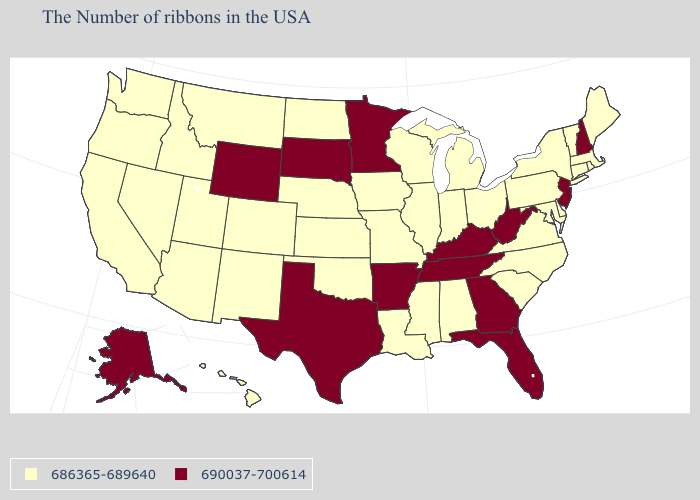Which states have the lowest value in the USA?
Short answer required. Maine, Massachusetts, Rhode Island, Vermont, Connecticut, New York, Delaware, Maryland, Pennsylvania, Virginia, North Carolina, South Carolina, Ohio, Michigan, Indiana, Alabama, Wisconsin, Illinois, Mississippi, Louisiana, Missouri, Iowa, Kansas, Nebraska, Oklahoma, North Dakota, Colorado, New Mexico, Utah, Montana, Arizona, Idaho, Nevada, California, Washington, Oregon, Hawaii. Name the states that have a value in the range 690037-700614?
Write a very short answer. New Hampshire, New Jersey, West Virginia, Florida, Georgia, Kentucky, Tennessee, Arkansas, Minnesota, Texas, South Dakota, Wyoming, Alaska. Does Colorado have the lowest value in the West?
Concise answer only. Yes. Name the states that have a value in the range 690037-700614?
Give a very brief answer. New Hampshire, New Jersey, West Virginia, Florida, Georgia, Kentucky, Tennessee, Arkansas, Minnesota, Texas, South Dakota, Wyoming, Alaska. Is the legend a continuous bar?
Write a very short answer. No. Name the states that have a value in the range 690037-700614?
Give a very brief answer. New Hampshire, New Jersey, West Virginia, Florida, Georgia, Kentucky, Tennessee, Arkansas, Minnesota, Texas, South Dakota, Wyoming, Alaska. What is the highest value in states that border Nevada?
Quick response, please. 686365-689640. What is the highest value in states that border Illinois?
Be succinct. 690037-700614. Among the states that border Maine , which have the lowest value?
Give a very brief answer. New Hampshire. How many symbols are there in the legend?
Concise answer only. 2. Name the states that have a value in the range 690037-700614?
Concise answer only. New Hampshire, New Jersey, West Virginia, Florida, Georgia, Kentucky, Tennessee, Arkansas, Minnesota, Texas, South Dakota, Wyoming, Alaska. Name the states that have a value in the range 686365-689640?
Answer briefly. Maine, Massachusetts, Rhode Island, Vermont, Connecticut, New York, Delaware, Maryland, Pennsylvania, Virginia, North Carolina, South Carolina, Ohio, Michigan, Indiana, Alabama, Wisconsin, Illinois, Mississippi, Louisiana, Missouri, Iowa, Kansas, Nebraska, Oklahoma, North Dakota, Colorado, New Mexico, Utah, Montana, Arizona, Idaho, Nevada, California, Washington, Oregon, Hawaii. Name the states that have a value in the range 686365-689640?
Write a very short answer. Maine, Massachusetts, Rhode Island, Vermont, Connecticut, New York, Delaware, Maryland, Pennsylvania, Virginia, North Carolina, South Carolina, Ohio, Michigan, Indiana, Alabama, Wisconsin, Illinois, Mississippi, Louisiana, Missouri, Iowa, Kansas, Nebraska, Oklahoma, North Dakota, Colorado, New Mexico, Utah, Montana, Arizona, Idaho, Nevada, California, Washington, Oregon, Hawaii. Name the states that have a value in the range 690037-700614?
Quick response, please. New Hampshire, New Jersey, West Virginia, Florida, Georgia, Kentucky, Tennessee, Arkansas, Minnesota, Texas, South Dakota, Wyoming, Alaska. Name the states that have a value in the range 686365-689640?
Concise answer only. Maine, Massachusetts, Rhode Island, Vermont, Connecticut, New York, Delaware, Maryland, Pennsylvania, Virginia, North Carolina, South Carolina, Ohio, Michigan, Indiana, Alabama, Wisconsin, Illinois, Mississippi, Louisiana, Missouri, Iowa, Kansas, Nebraska, Oklahoma, North Dakota, Colorado, New Mexico, Utah, Montana, Arizona, Idaho, Nevada, California, Washington, Oregon, Hawaii. 